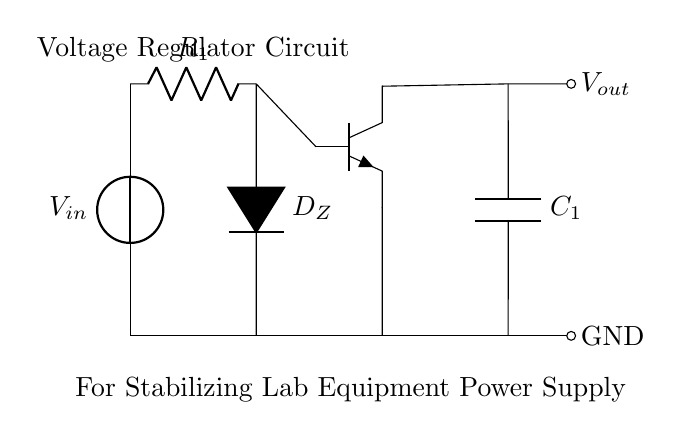What is the type of diode used in this circuit? The symbol used in the circuit is a Zener diode, which is denoted by the label D_Z. This type of diode is specifically designed to operate in the reverse breakdown region, allowing it to maintain a stable output voltage.
Answer: Zener diode What component is connected to the base of the transistor? The circuit shows that the Zener diode (D_Z) is connected to the base of the transistor. This connection helps regulate the voltage by controlling the transistor's conduction based on the voltage across the Zener.
Answer: Zener diode What is the function of capacitor C1 in this circuit? Capacitor C1 is used to smooth the output voltage, filtering out any ripple and providing a stable power supply to sensitive lab equipment. Capacitors in power supply circuits usually stabilize voltage levels.
Answer: Smoothing What role does resistor R1 play in this voltage regulator? Resistor R1 is in series with the input voltage and the Zener diode, limiting the current through the Zener diode to prevent damage while maintaining the voltage across it at the desired value.
Answer: Current limiting What is the output voltage represented in the circuit? The output voltage is denoted by the label V_out, which is connected to the output capacitor and is stabilized by the feedback from the Zener diode and the transistor's operation.
Answer: V_out How does the transistor contribute to voltage regulation in this circuit? The transistor acts as a switch and amplifier in the circuit, stabilizing the output voltage by adjusting its conduction based on the base voltage received from the Zener diode. This feedback loop helps keep V_out steady despite variations in input voltage or load.
Answer: Feedback stabilization What type of circuit configuration is shown here? This circuit configuration is a voltage regulator, specifically designed to stable the output voltage from a varying input voltage for sensitive applications, such as laboratory equipment.
Answer: Voltage regulator 